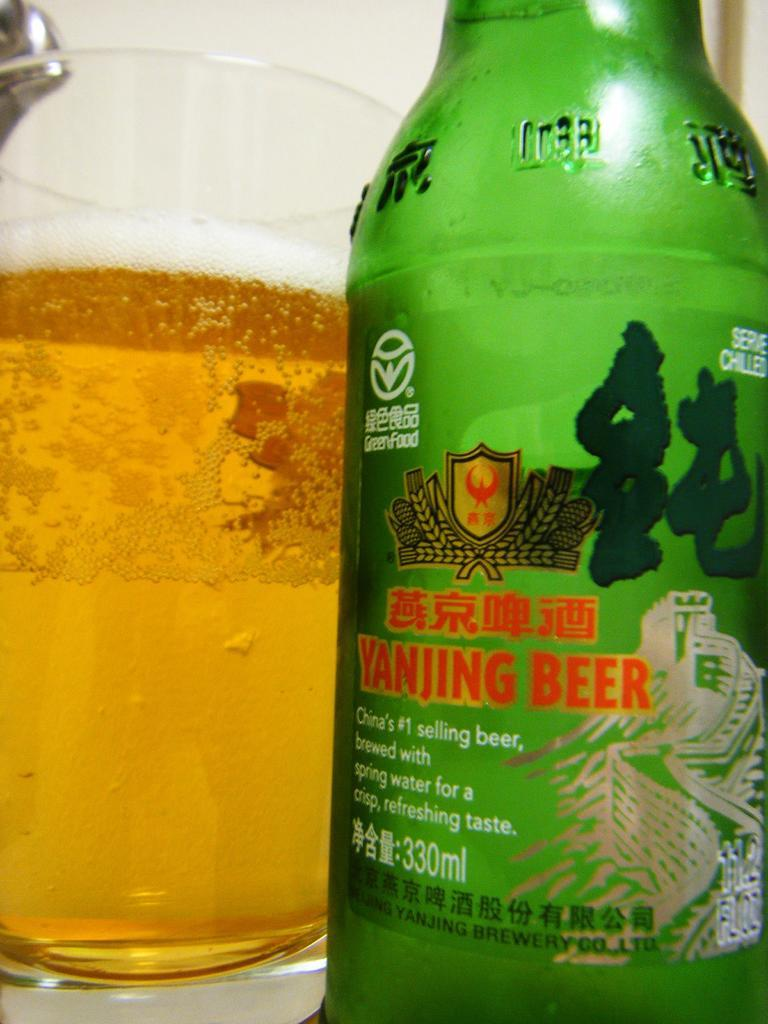<image>
Present a compact description of the photo's key features. A full glass next to a bottle of Yanjing Beer. 